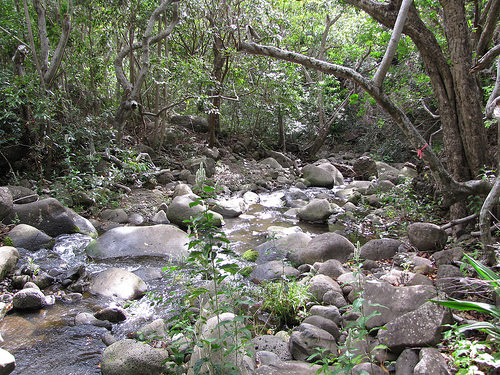<image>
Can you confirm if the rocks is behind the river? No. The rocks is not behind the river. From this viewpoint, the rocks appears to be positioned elsewhere in the scene. 